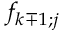Convert formula to latex. <formula><loc_0><loc_0><loc_500><loc_500>f _ { k \mp 1 ; j }</formula> 